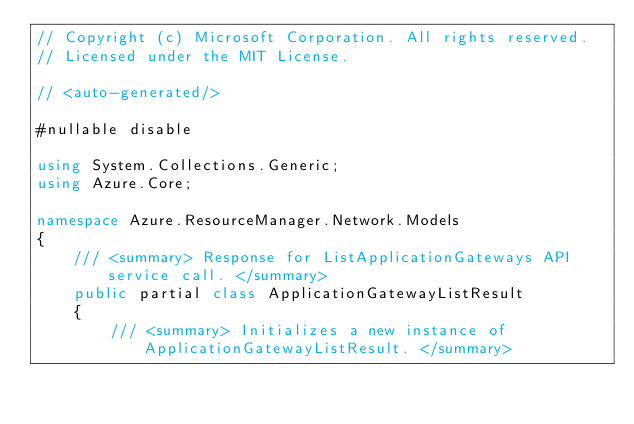<code> <loc_0><loc_0><loc_500><loc_500><_C#_>// Copyright (c) Microsoft Corporation. All rights reserved.
// Licensed under the MIT License.

// <auto-generated/>

#nullable disable

using System.Collections.Generic;
using Azure.Core;

namespace Azure.ResourceManager.Network.Models
{
    /// <summary> Response for ListApplicationGateways API service call. </summary>
    public partial class ApplicationGatewayListResult
    {
        /// <summary> Initializes a new instance of ApplicationGatewayListResult. </summary></code> 